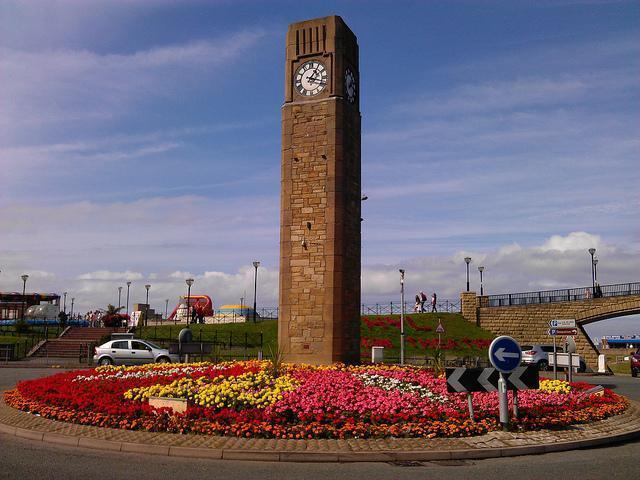How many red kites are there?
Give a very brief answer. 0. 